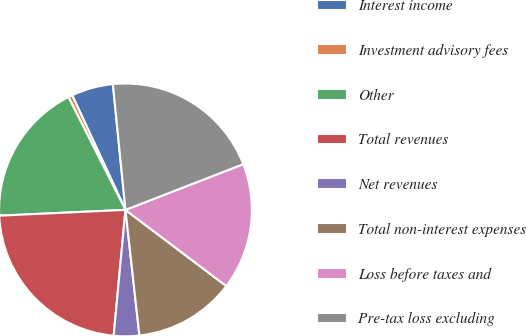<chart> <loc_0><loc_0><loc_500><loc_500><pie_chart><fcel>Interest income<fcel>Investment advisory fees<fcel>Other<fcel>Total revenues<fcel>Net revenues<fcel>Total non-interest expenses<fcel>Loss before taxes and<fcel>Pre-tax loss excluding<nl><fcel>5.34%<fcel>0.52%<fcel>18.28%<fcel>22.78%<fcel>3.25%<fcel>12.94%<fcel>16.19%<fcel>20.69%<nl></chart> 